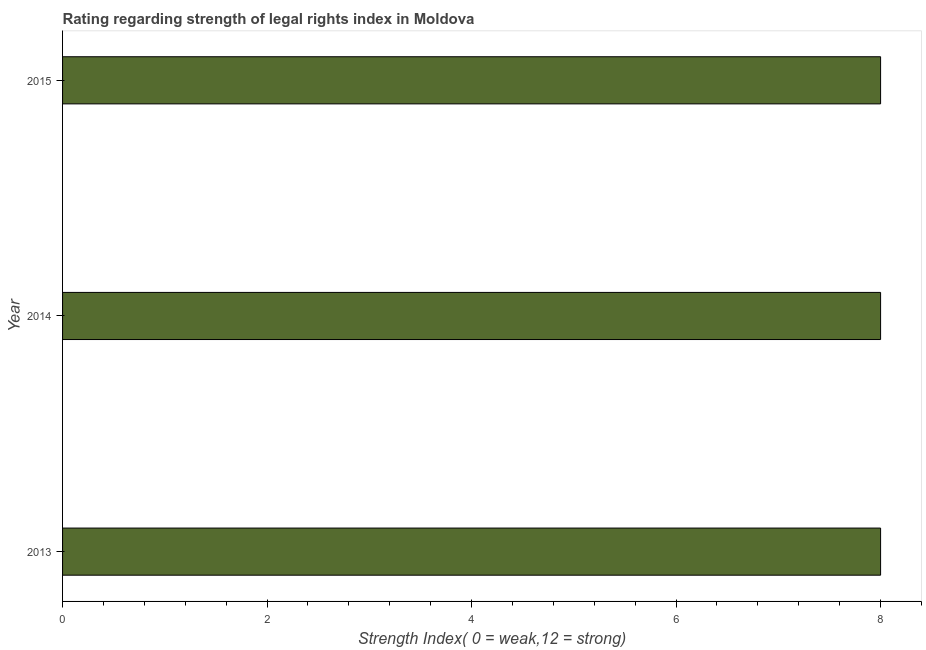Does the graph contain grids?
Offer a terse response. No. What is the title of the graph?
Give a very brief answer. Rating regarding strength of legal rights index in Moldova. What is the label or title of the X-axis?
Offer a very short reply. Strength Index( 0 = weak,12 = strong). What is the strength of legal rights index in 2014?
Make the answer very short. 8. In which year was the strength of legal rights index minimum?
Ensure brevity in your answer.  2013. What is the sum of the strength of legal rights index?
Your answer should be compact. 24. What is the average strength of legal rights index per year?
Provide a succinct answer. 8. What is the median strength of legal rights index?
Provide a short and direct response. 8. Do a majority of the years between 2015 and 2014 (inclusive) have strength of legal rights index greater than 2.8 ?
Your response must be concise. No. What is the ratio of the strength of legal rights index in 2013 to that in 2015?
Offer a very short reply. 1. Is the sum of the strength of legal rights index in 2014 and 2015 greater than the maximum strength of legal rights index across all years?
Ensure brevity in your answer.  Yes. How many bars are there?
Keep it short and to the point. 3. Are all the bars in the graph horizontal?
Offer a very short reply. Yes. What is the Strength Index( 0 = weak,12 = strong) of 2013?
Ensure brevity in your answer.  8. What is the Strength Index( 0 = weak,12 = strong) of 2014?
Offer a very short reply. 8. What is the Strength Index( 0 = weak,12 = strong) in 2015?
Make the answer very short. 8. What is the difference between the Strength Index( 0 = weak,12 = strong) in 2013 and 2014?
Make the answer very short. 0. What is the difference between the Strength Index( 0 = weak,12 = strong) in 2013 and 2015?
Make the answer very short. 0. What is the difference between the Strength Index( 0 = weak,12 = strong) in 2014 and 2015?
Offer a very short reply. 0. What is the ratio of the Strength Index( 0 = weak,12 = strong) in 2013 to that in 2014?
Offer a very short reply. 1. 